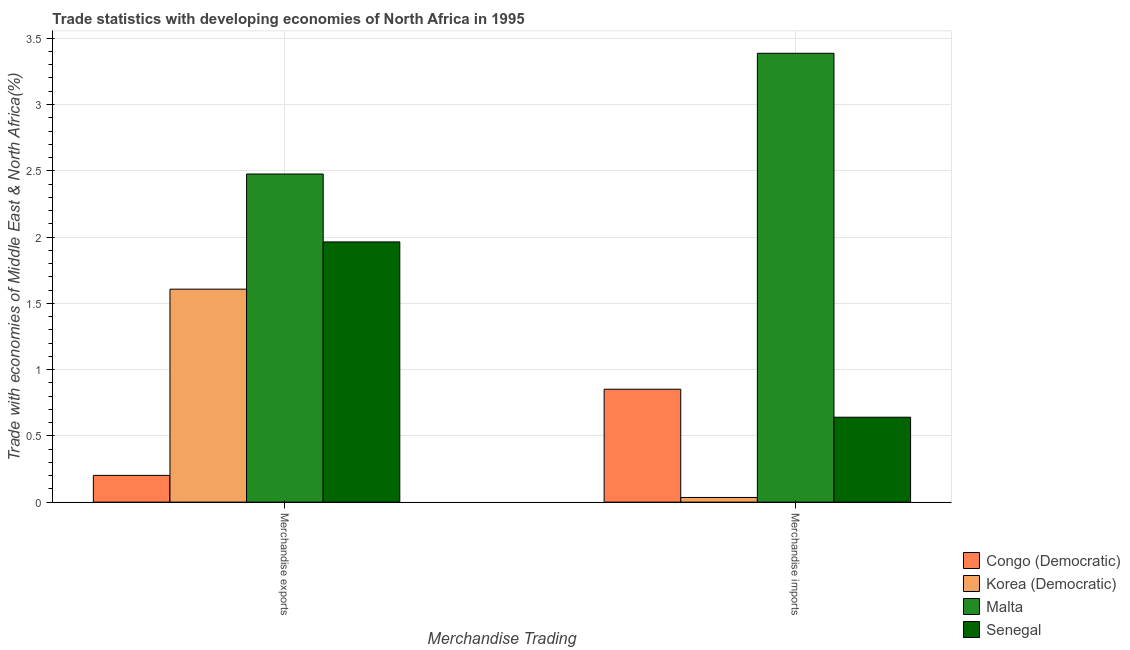How many groups of bars are there?
Provide a succinct answer. 2. Are the number of bars per tick equal to the number of legend labels?
Ensure brevity in your answer.  Yes. Are the number of bars on each tick of the X-axis equal?
Your response must be concise. Yes. How many bars are there on the 2nd tick from the left?
Offer a terse response. 4. How many bars are there on the 1st tick from the right?
Provide a short and direct response. 4. What is the label of the 2nd group of bars from the left?
Your answer should be compact. Merchandise imports. What is the merchandise exports in Senegal?
Your answer should be very brief. 1.96. Across all countries, what is the maximum merchandise exports?
Offer a terse response. 2.48. Across all countries, what is the minimum merchandise exports?
Your answer should be very brief. 0.2. In which country was the merchandise exports maximum?
Provide a succinct answer. Malta. In which country was the merchandise imports minimum?
Your response must be concise. Korea (Democratic). What is the total merchandise imports in the graph?
Make the answer very short. 4.91. What is the difference between the merchandise exports in Malta and that in Korea (Democratic)?
Give a very brief answer. 0.87. What is the difference between the merchandise exports in Korea (Democratic) and the merchandise imports in Congo (Democratic)?
Ensure brevity in your answer.  0.75. What is the average merchandise imports per country?
Offer a terse response. 1.23. What is the difference between the merchandise exports and merchandise imports in Senegal?
Make the answer very short. 1.32. In how many countries, is the merchandise exports greater than 0.4 %?
Offer a terse response. 3. What is the ratio of the merchandise imports in Malta to that in Korea (Democratic)?
Your answer should be very brief. 96.35. In how many countries, is the merchandise imports greater than the average merchandise imports taken over all countries?
Offer a terse response. 1. What does the 1st bar from the left in Merchandise exports represents?
Provide a short and direct response. Congo (Democratic). What does the 2nd bar from the right in Merchandise imports represents?
Provide a succinct answer. Malta. How many bars are there?
Ensure brevity in your answer.  8. How many countries are there in the graph?
Give a very brief answer. 4. Are the values on the major ticks of Y-axis written in scientific E-notation?
Make the answer very short. No. Does the graph contain any zero values?
Your answer should be very brief. No. How many legend labels are there?
Your response must be concise. 4. What is the title of the graph?
Make the answer very short. Trade statistics with developing economies of North Africa in 1995. Does "Lesotho" appear as one of the legend labels in the graph?
Offer a very short reply. No. What is the label or title of the X-axis?
Provide a succinct answer. Merchandise Trading. What is the label or title of the Y-axis?
Offer a very short reply. Trade with economies of Middle East & North Africa(%). What is the Trade with economies of Middle East & North Africa(%) in Congo (Democratic) in Merchandise exports?
Your response must be concise. 0.2. What is the Trade with economies of Middle East & North Africa(%) in Korea (Democratic) in Merchandise exports?
Give a very brief answer. 1.61. What is the Trade with economies of Middle East & North Africa(%) of Malta in Merchandise exports?
Provide a succinct answer. 2.48. What is the Trade with economies of Middle East & North Africa(%) in Senegal in Merchandise exports?
Your answer should be very brief. 1.96. What is the Trade with economies of Middle East & North Africa(%) of Congo (Democratic) in Merchandise imports?
Offer a very short reply. 0.85. What is the Trade with economies of Middle East & North Africa(%) of Korea (Democratic) in Merchandise imports?
Your answer should be very brief. 0.04. What is the Trade with economies of Middle East & North Africa(%) in Malta in Merchandise imports?
Ensure brevity in your answer.  3.39. What is the Trade with economies of Middle East & North Africa(%) of Senegal in Merchandise imports?
Your answer should be compact. 0.64. Across all Merchandise Trading, what is the maximum Trade with economies of Middle East & North Africa(%) in Congo (Democratic)?
Ensure brevity in your answer.  0.85. Across all Merchandise Trading, what is the maximum Trade with economies of Middle East & North Africa(%) in Korea (Democratic)?
Keep it short and to the point. 1.61. Across all Merchandise Trading, what is the maximum Trade with economies of Middle East & North Africa(%) in Malta?
Provide a short and direct response. 3.39. Across all Merchandise Trading, what is the maximum Trade with economies of Middle East & North Africa(%) in Senegal?
Provide a succinct answer. 1.96. Across all Merchandise Trading, what is the minimum Trade with economies of Middle East & North Africa(%) of Congo (Democratic)?
Ensure brevity in your answer.  0.2. Across all Merchandise Trading, what is the minimum Trade with economies of Middle East & North Africa(%) of Korea (Democratic)?
Provide a short and direct response. 0.04. Across all Merchandise Trading, what is the minimum Trade with economies of Middle East & North Africa(%) of Malta?
Make the answer very short. 2.48. Across all Merchandise Trading, what is the minimum Trade with economies of Middle East & North Africa(%) of Senegal?
Make the answer very short. 0.64. What is the total Trade with economies of Middle East & North Africa(%) of Congo (Democratic) in the graph?
Offer a terse response. 1.05. What is the total Trade with economies of Middle East & North Africa(%) of Korea (Democratic) in the graph?
Your answer should be compact. 1.64. What is the total Trade with economies of Middle East & North Africa(%) in Malta in the graph?
Your response must be concise. 5.86. What is the total Trade with economies of Middle East & North Africa(%) of Senegal in the graph?
Your answer should be very brief. 2.6. What is the difference between the Trade with economies of Middle East & North Africa(%) of Congo (Democratic) in Merchandise exports and that in Merchandise imports?
Your answer should be very brief. -0.65. What is the difference between the Trade with economies of Middle East & North Africa(%) in Korea (Democratic) in Merchandise exports and that in Merchandise imports?
Offer a terse response. 1.57. What is the difference between the Trade with economies of Middle East & North Africa(%) of Malta in Merchandise exports and that in Merchandise imports?
Give a very brief answer. -0.91. What is the difference between the Trade with economies of Middle East & North Africa(%) in Senegal in Merchandise exports and that in Merchandise imports?
Your response must be concise. 1.32. What is the difference between the Trade with economies of Middle East & North Africa(%) of Congo (Democratic) in Merchandise exports and the Trade with economies of Middle East & North Africa(%) of Korea (Democratic) in Merchandise imports?
Your answer should be compact. 0.17. What is the difference between the Trade with economies of Middle East & North Africa(%) in Congo (Democratic) in Merchandise exports and the Trade with economies of Middle East & North Africa(%) in Malta in Merchandise imports?
Give a very brief answer. -3.18. What is the difference between the Trade with economies of Middle East & North Africa(%) of Congo (Democratic) in Merchandise exports and the Trade with economies of Middle East & North Africa(%) of Senegal in Merchandise imports?
Offer a terse response. -0.44. What is the difference between the Trade with economies of Middle East & North Africa(%) of Korea (Democratic) in Merchandise exports and the Trade with economies of Middle East & North Africa(%) of Malta in Merchandise imports?
Offer a terse response. -1.78. What is the difference between the Trade with economies of Middle East & North Africa(%) in Korea (Democratic) in Merchandise exports and the Trade with economies of Middle East & North Africa(%) in Senegal in Merchandise imports?
Offer a terse response. 0.97. What is the difference between the Trade with economies of Middle East & North Africa(%) in Malta in Merchandise exports and the Trade with economies of Middle East & North Africa(%) in Senegal in Merchandise imports?
Make the answer very short. 1.83. What is the average Trade with economies of Middle East & North Africa(%) in Congo (Democratic) per Merchandise Trading?
Your answer should be compact. 0.53. What is the average Trade with economies of Middle East & North Africa(%) in Korea (Democratic) per Merchandise Trading?
Your response must be concise. 0.82. What is the average Trade with economies of Middle East & North Africa(%) of Malta per Merchandise Trading?
Provide a succinct answer. 2.93. What is the average Trade with economies of Middle East & North Africa(%) in Senegal per Merchandise Trading?
Ensure brevity in your answer.  1.3. What is the difference between the Trade with economies of Middle East & North Africa(%) of Congo (Democratic) and Trade with economies of Middle East & North Africa(%) of Korea (Democratic) in Merchandise exports?
Ensure brevity in your answer.  -1.41. What is the difference between the Trade with economies of Middle East & North Africa(%) in Congo (Democratic) and Trade with economies of Middle East & North Africa(%) in Malta in Merchandise exports?
Your answer should be very brief. -2.27. What is the difference between the Trade with economies of Middle East & North Africa(%) in Congo (Democratic) and Trade with economies of Middle East & North Africa(%) in Senegal in Merchandise exports?
Offer a terse response. -1.76. What is the difference between the Trade with economies of Middle East & North Africa(%) of Korea (Democratic) and Trade with economies of Middle East & North Africa(%) of Malta in Merchandise exports?
Offer a terse response. -0.87. What is the difference between the Trade with economies of Middle East & North Africa(%) of Korea (Democratic) and Trade with economies of Middle East & North Africa(%) of Senegal in Merchandise exports?
Ensure brevity in your answer.  -0.36. What is the difference between the Trade with economies of Middle East & North Africa(%) of Malta and Trade with economies of Middle East & North Africa(%) of Senegal in Merchandise exports?
Your answer should be compact. 0.51. What is the difference between the Trade with economies of Middle East & North Africa(%) in Congo (Democratic) and Trade with economies of Middle East & North Africa(%) in Korea (Democratic) in Merchandise imports?
Give a very brief answer. 0.82. What is the difference between the Trade with economies of Middle East & North Africa(%) in Congo (Democratic) and Trade with economies of Middle East & North Africa(%) in Malta in Merchandise imports?
Make the answer very short. -2.53. What is the difference between the Trade with economies of Middle East & North Africa(%) of Congo (Democratic) and Trade with economies of Middle East & North Africa(%) of Senegal in Merchandise imports?
Ensure brevity in your answer.  0.21. What is the difference between the Trade with economies of Middle East & North Africa(%) of Korea (Democratic) and Trade with economies of Middle East & North Africa(%) of Malta in Merchandise imports?
Your answer should be compact. -3.35. What is the difference between the Trade with economies of Middle East & North Africa(%) of Korea (Democratic) and Trade with economies of Middle East & North Africa(%) of Senegal in Merchandise imports?
Offer a terse response. -0.61. What is the difference between the Trade with economies of Middle East & North Africa(%) in Malta and Trade with economies of Middle East & North Africa(%) in Senegal in Merchandise imports?
Keep it short and to the point. 2.75. What is the ratio of the Trade with economies of Middle East & North Africa(%) of Congo (Democratic) in Merchandise exports to that in Merchandise imports?
Your answer should be very brief. 0.24. What is the ratio of the Trade with economies of Middle East & North Africa(%) in Korea (Democratic) in Merchandise exports to that in Merchandise imports?
Keep it short and to the point. 45.71. What is the ratio of the Trade with economies of Middle East & North Africa(%) in Malta in Merchandise exports to that in Merchandise imports?
Make the answer very short. 0.73. What is the ratio of the Trade with economies of Middle East & North Africa(%) of Senegal in Merchandise exports to that in Merchandise imports?
Keep it short and to the point. 3.06. What is the difference between the highest and the second highest Trade with economies of Middle East & North Africa(%) in Congo (Democratic)?
Offer a terse response. 0.65. What is the difference between the highest and the second highest Trade with economies of Middle East & North Africa(%) of Korea (Democratic)?
Keep it short and to the point. 1.57. What is the difference between the highest and the second highest Trade with economies of Middle East & North Africa(%) of Malta?
Keep it short and to the point. 0.91. What is the difference between the highest and the second highest Trade with economies of Middle East & North Africa(%) of Senegal?
Ensure brevity in your answer.  1.32. What is the difference between the highest and the lowest Trade with economies of Middle East & North Africa(%) in Congo (Democratic)?
Offer a terse response. 0.65. What is the difference between the highest and the lowest Trade with economies of Middle East & North Africa(%) in Korea (Democratic)?
Provide a short and direct response. 1.57. What is the difference between the highest and the lowest Trade with economies of Middle East & North Africa(%) of Malta?
Give a very brief answer. 0.91. What is the difference between the highest and the lowest Trade with economies of Middle East & North Africa(%) in Senegal?
Provide a succinct answer. 1.32. 